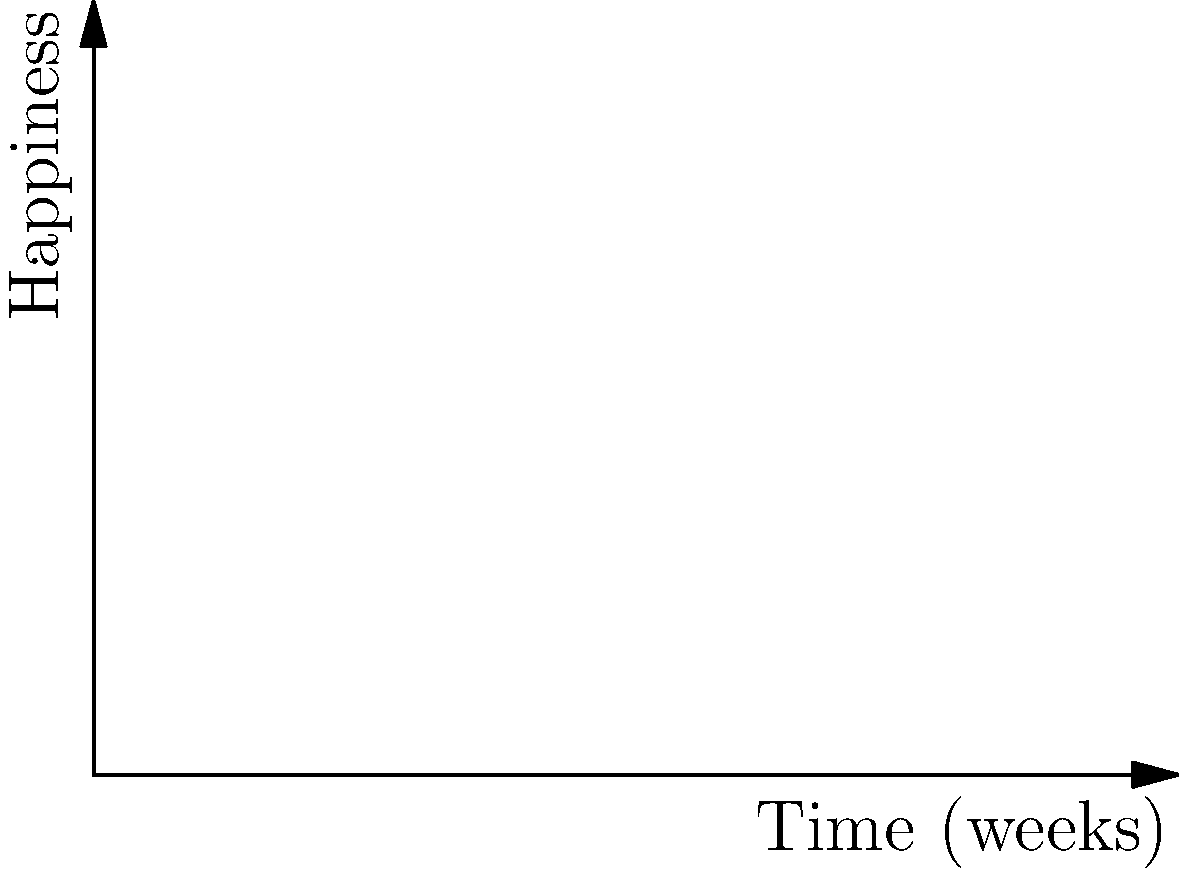You're planning a trip to visit both your adoptive family in New Zealand and your birth family in Russia. Your happiness level (on a scale of 0-40) with each family over time can be modeled by the following functions:

New Zealand family: $f(x) = -0.5x^2 + 6x + 10$
Russian family: $g(x) = 0.25x^2 - 2x + 20$

Where $x$ is the number of weeks into your trip. To maximize your overall happiness, at what point (in weeks) should you transition from visiting one family to the other, and what is the maximum combined happiness level at this point? To find the optimal transition point, we need to determine where the two happiness functions intersect:

1) Set the equations equal to each other:
   $-0.5x^2 + 6x + 10 = 0.25x^2 - 2x + 20$

2) Rearrange the equation:
   $-0.75x^2 + 8x - 10 = 0$

3) This is a quadratic equation. We can solve it using the quadratic formula:
   $x = \frac{-b \pm \sqrt{b^2 - 4ac}}{2a}$

   Where $a = -0.75$, $b = 8$, and $c = -10$

4) Plugging in these values:
   $x = \frac{-8 \pm \sqrt{64 - 4(-0.75)(-10)}}{2(-0.75)}$
   $x = \frac{-8 \pm \sqrt{64 - 30}}{-1.5}$
   $x = \frac{-8 \pm \sqrt{34}}{-1.5}$

5) This gives us two solutions:
   $x_1 \approx 6$ weeks
   $x_2 \approx 10.67$ weeks (which is outside our domain of interest)

6) The intersection point occurs at approximately 6 weeks.

7) To find the happiness level at this point, we can plug x = 6 into either function:
   $f(6) = -0.5(6)^2 + 6(6) + 10 = -18 + 36 + 10 = 28$

Therefore, the optimal time to transition between families is at 6 weeks, with a maximum combined happiness level of 28.
Answer: Transition at 6 weeks; maximum happiness level of 28. 